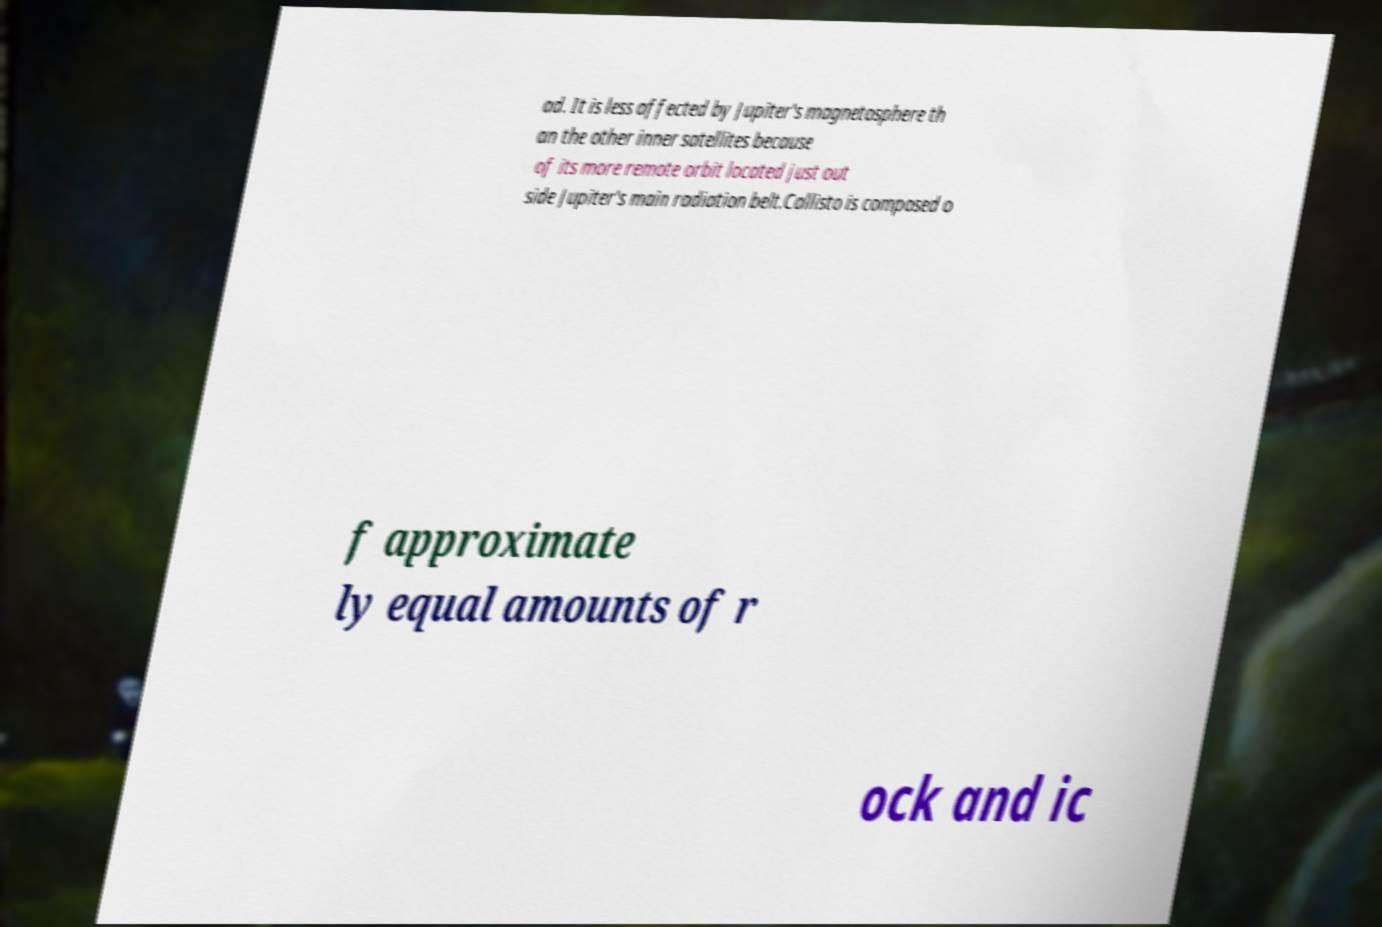What messages or text are displayed in this image? I need them in a readable, typed format. ad. It is less affected by Jupiter's magnetosphere th an the other inner satellites because of its more remote orbit located just out side Jupiter's main radiation belt.Callisto is composed o f approximate ly equal amounts of r ock and ic 